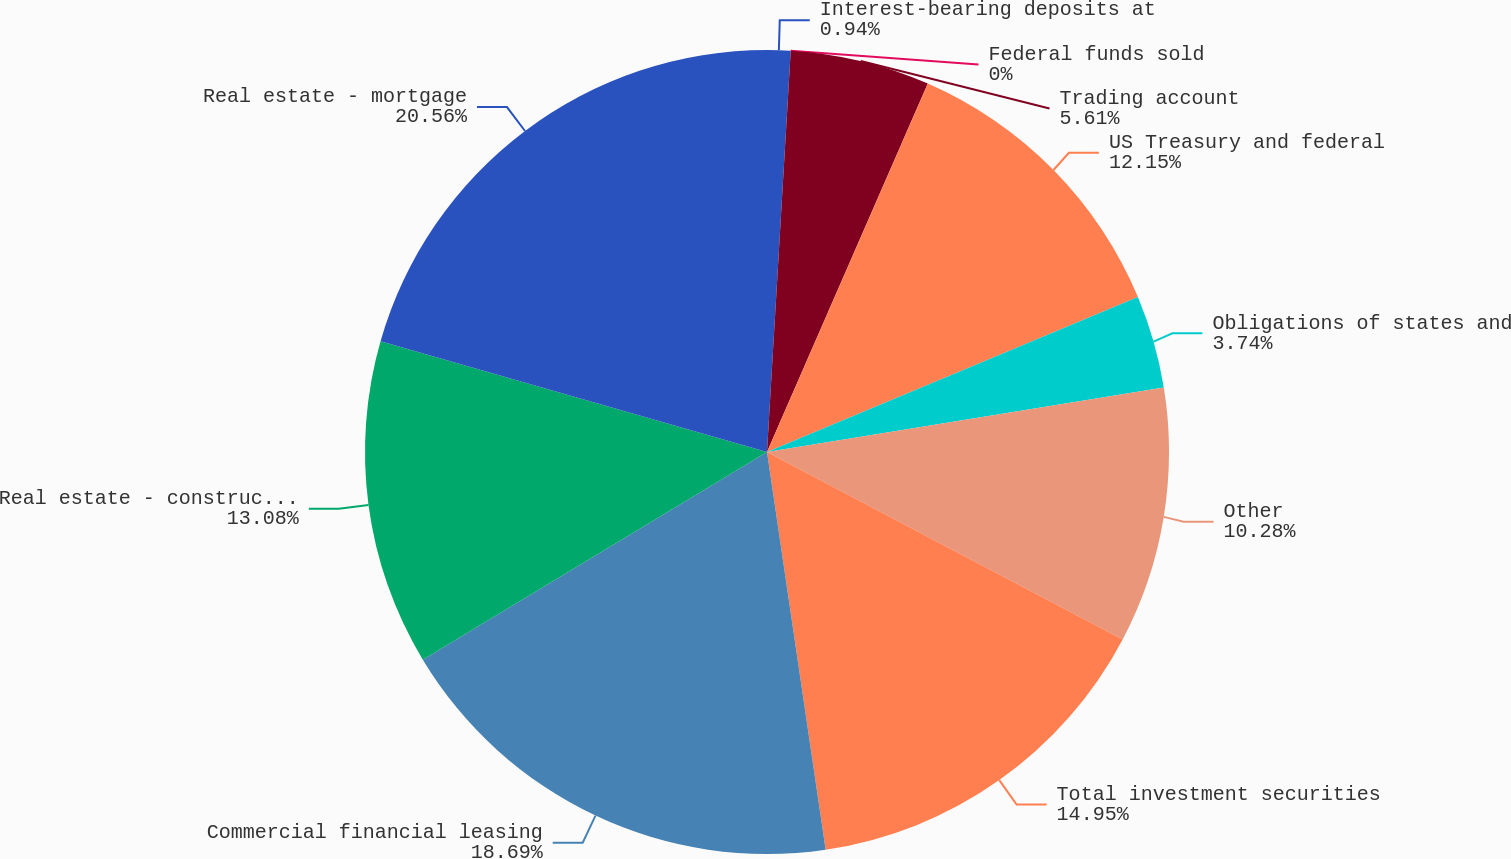Convert chart to OTSL. <chart><loc_0><loc_0><loc_500><loc_500><pie_chart><fcel>Interest-bearing deposits at<fcel>Federal funds sold<fcel>Trading account<fcel>US Treasury and federal<fcel>Obligations of states and<fcel>Other<fcel>Total investment securities<fcel>Commercial financial leasing<fcel>Real estate - construction<fcel>Real estate - mortgage<nl><fcel>0.94%<fcel>0.0%<fcel>5.61%<fcel>12.15%<fcel>3.74%<fcel>10.28%<fcel>14.95%<fcel>18.69%<fcel>13.08%<fcel>20.56%<nl></chart> 